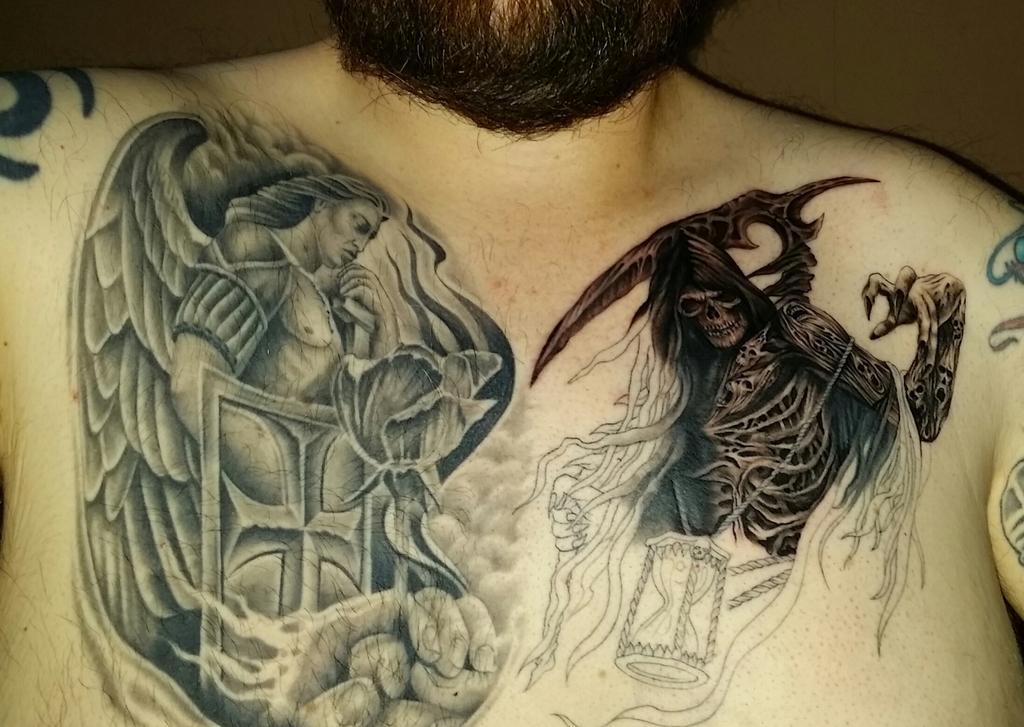What is present in the image? There is a person in the image. Can you describe any distinguishing features of the person? The person has tattoos on their chest and a beard. What type of record can be seen on the mountain in the image? There is no record or mountain present in the image; it only features a person with tattoos and a beard. 